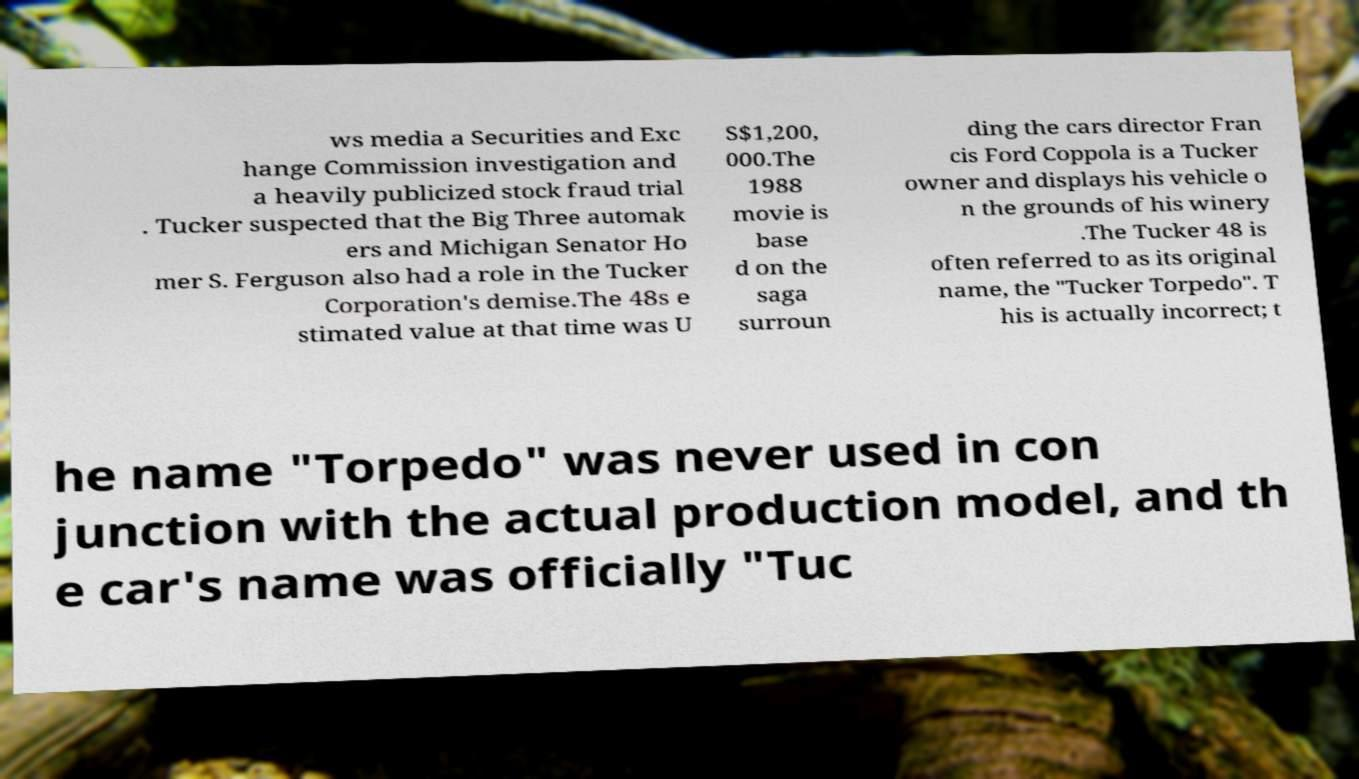Please read and relay the text visible in this image. What does it say? ws media a Securities and Exc hange Commission investigation and a heavily publicized stock fraud trial . Tucker suspected that the Big Three automak ers and Michigan Senator Ho mer S. Ferguson also had a role in the Tucker Corporation's demise.The 48s e stimated value at that time was U S$1,200, 000.The 1988 movie is base d on the saga surroun ding the cars director Fran cis Ford Coppola is a Tucker owner and displays his vehicle o n the grounds of his winery .The Tucker 48 is often referred to as its original name, the "Tucker Torpedo". T his is actually incorrect; t he name "Torpedo" was never used in con junction with the actual production model, and th e car's name was officially "Tuc 